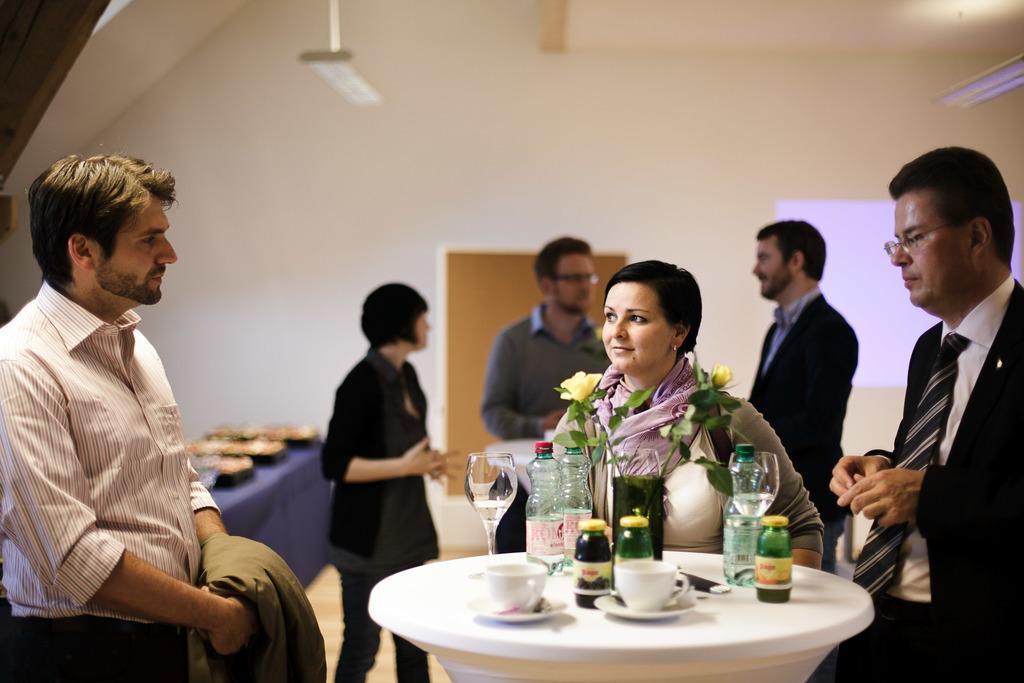Describe this image in one or two sentences. In this image there are four men standing, there are two women standing, there is a man holding a cloth, there is a table towards the bottom of the image, there are objects on the table, there is a light towards the right of the image, there is an object towards the top of the image, there is a board behind the man, at the background of the image there is a wall. 